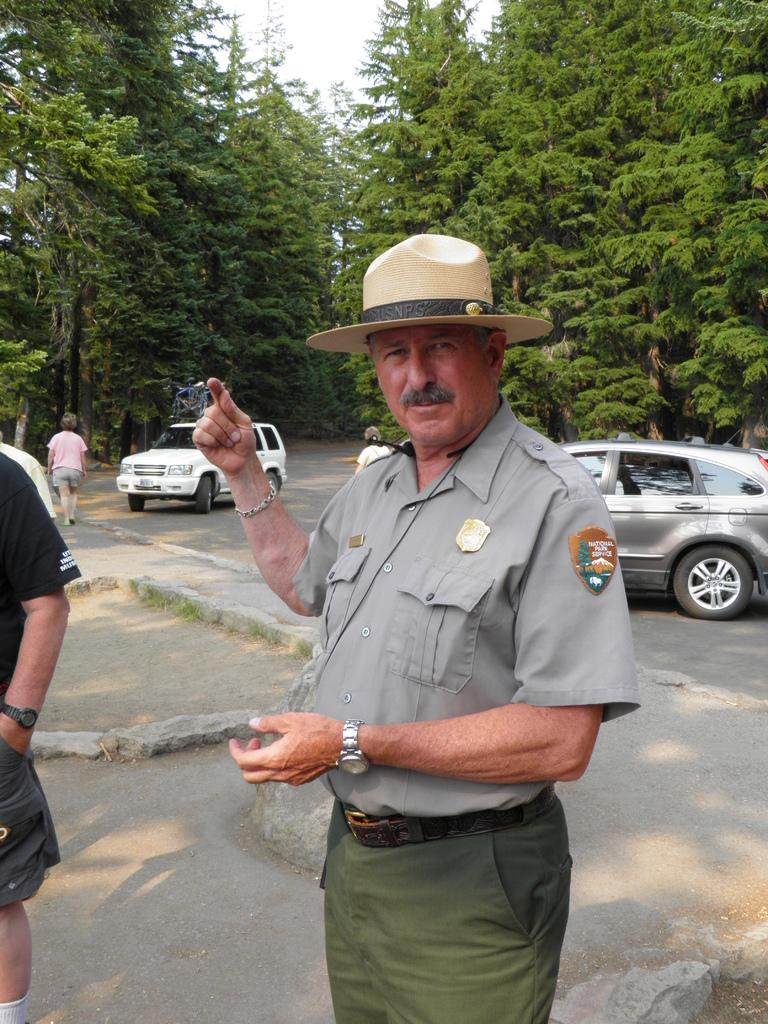What can be seen in the image? There are people and vehicles on the road in the image. Can you describe the appearance of one of the people? One person is wearing a hat. What is visible in the background of the image? There are many trees and the sky in the background of the image. What type of food is being served at the point in the image? There is no food or point visible in the image. 